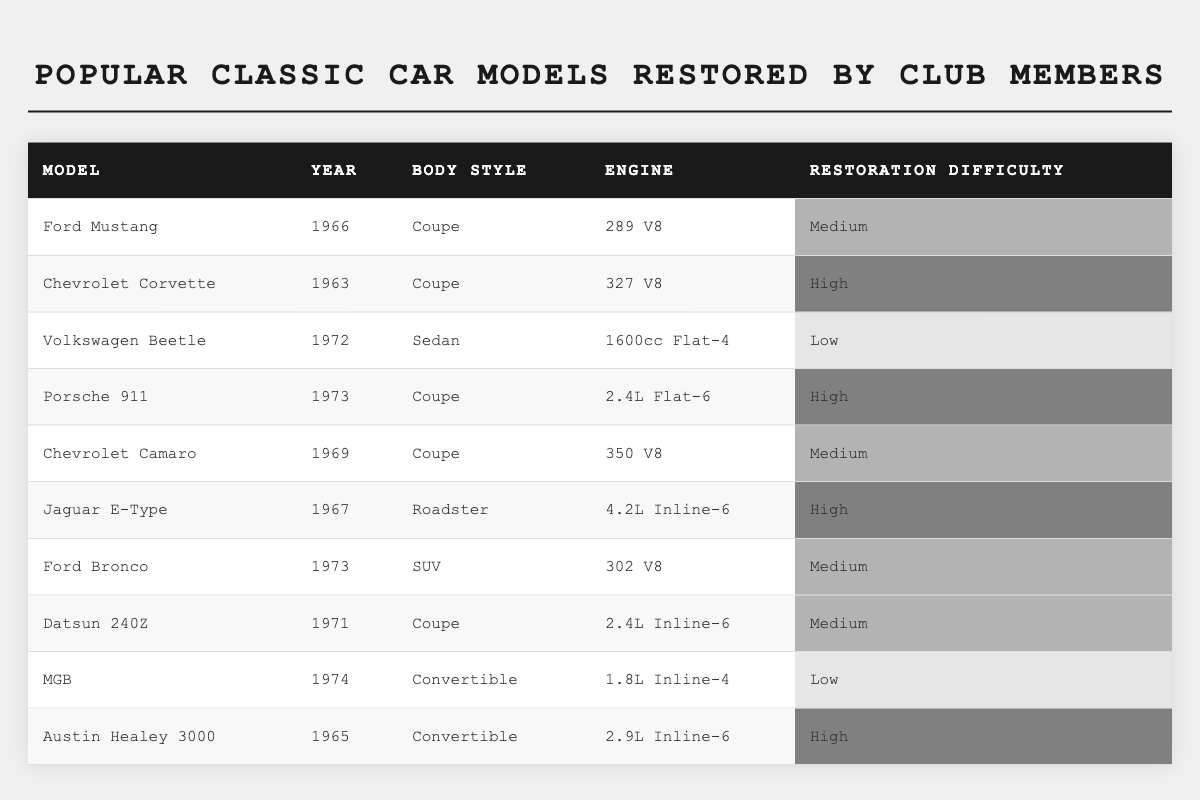What is the body style of the 1966 Ford Mustang? The table lists the body style in the row corresponding to the model "Ford Mustang" from the year 1966, which shows it as "Coupe."
Answer: Coupe Which car has the highest restoration difficulty and what is it? Scanning the "Restoration Difficulty" column, "High" is present for multiple models; the "Chevrolet Corvette" from 1963 and "Jaguar E-Type" from 1967 both have "High" listed, but in the context, I will take the first occurrence which is the "Chevrolet Corvette."
Answer: Chevrolet Corvette How many models have a medium restoration difficulty? Counting the entries marked "Medium" in the "Restoration Difficulty" column, the models are "Ford Mustang," "Chevrolet Camaro," "Ford Bronco," and "Datsun 240Z," totaling four models.
Answer: 4 Is the Volkswagen Beetle a coupe? The table shows that the "Volkswagen Beetle" from 1972 is classified as "Sedan," which means it is not a coupe.
Answer: No What is the engine type of the 1967 Jaguar E-Type? Referring to the row for "Jaguar E-Type," the engine type listed is "4.2L Inline-6."
Answer: 4.2L Inline-6 Which model has the lowest restoration difficulty, and what year was it made? The "MGB" from 1974 has "Low" listed for its restoration difficulty, making it the model with the lowest level of difficulty.
Answer: MGB, 1974 How many different body styles are represented in the table? Listing the body styles from the table: "Coupe," "Sedan," "Roadster," "SUV," and "Convertible," there are five unique body styles present.
Answer: 5 Which models were made in the 1970s? The 1970s models include the "Volkswagen Beetle" (1972), "Porsche 911" (1973), "Ford Bronco" (1973), "Datsun 240Z" (1971), and "MGB" (1974), totaling five models.
Answer: 5 Is there any model listed with a Flat-4 engine type? Checking the "Engine" column, the "Volkswagen Beetle" from 1972 has a "1600cc Flat-4" engine type, confirming it exists in the table.
Answer: Yes What are the years of the models that have a "High" restoration difficulty? The models with "High" difficulty are "Chevrolet Corvette" (1963), "Porsche 911" (1973), "Jaguar E-Type" (1967), and "Austin Healey 3000" (1965), which corresponds to the years: 1963, 1967, 1973, 1965.
Answer: 1963, 1967, 1973, 1965 Which body style has the most models listed in the table? By checking the body styles, "Coupe" appears three times for the models (Ford Mustang, Chevrolet Camaro, Porsche 911), which is more than any other body style listed.
Answer: Coupe 